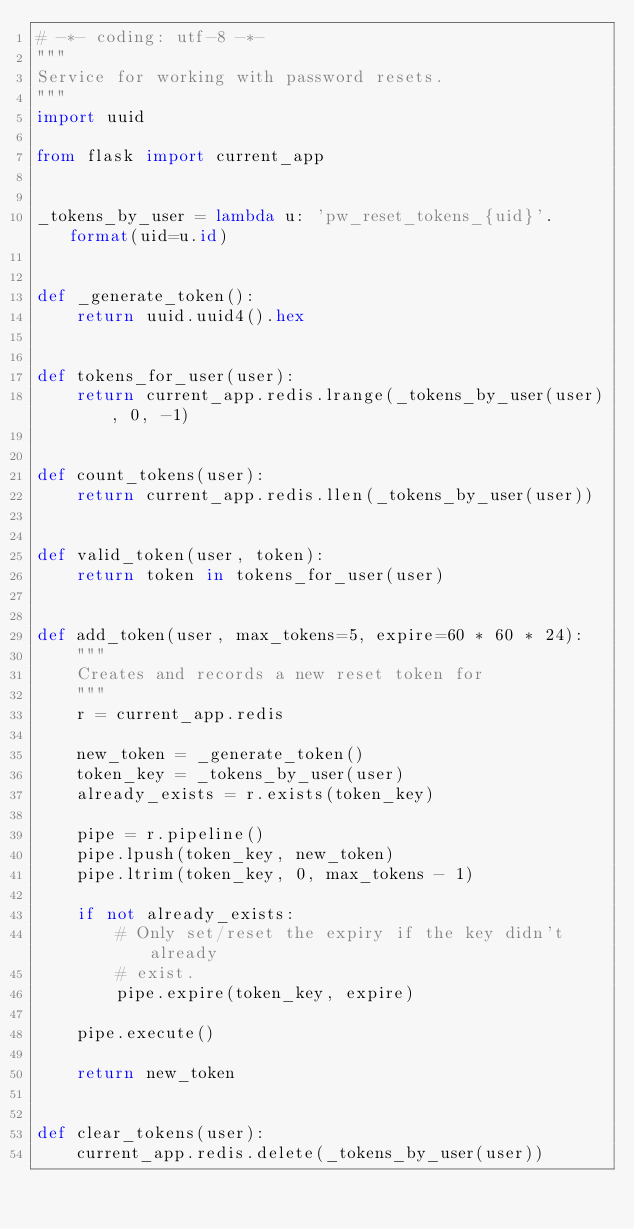<code> <loc_0><loc_0><loc_500><loc_500><_Python_># -*- coding: utf-8 -*-
"""
Service for working with password resets.
"""
import uuid

from flask import current_app


_tokens_by_user = lambda u: 'pw_reset_tokens_{uid}'.format(uid=u.id)


def _generate_token():
    return uuid.uuid4().hex


def tokens_for_user(user):
    return current_app.redis.lrange(_tokens_by_user(user), 0, -1)


def count_tokens(user):
    return current_app.redis.llen(_tokens_by_user(user))


def valid_token(user, token):
    return token in tokens_for_user(user)


def add_token(user, max_tokens=5, expire=60 * 60 * 24):
    """
    Creates and records a new reset token for
    """
    r = current_app.redis

    new_token = _generate_token()
    token_key = _tokens_by_user(user)
    already_exists = r.exists(token_key)

    pipe = r.pipeline()
    pipe.lpush(token_key, new_token)
    pipe.ltrim(token_key, 0, max_tokens - 1)

    if not already_exists:
        # Only set/reset the expiry if the key didn't already
        # exist.
        pipe.expire(token_key, expire)

    pipe.execute()

    return new_token


def clear_tokens(user):
    current_app.redis.delete(_tokens_by_user(user))
</code> 